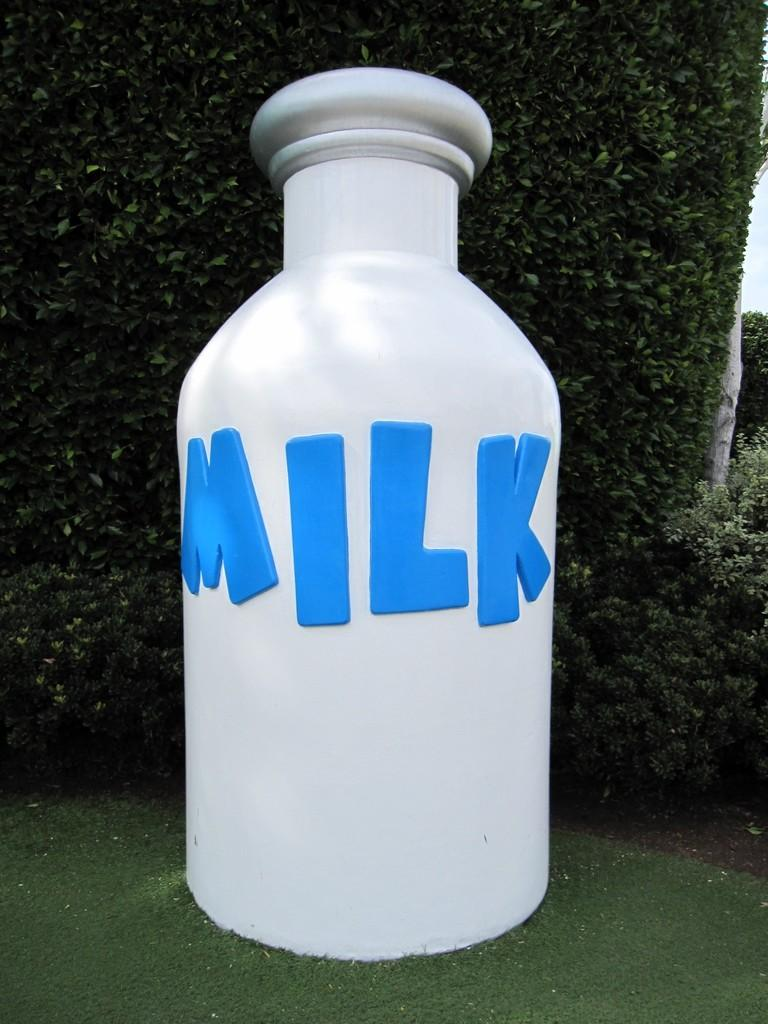<image>
Summarize the visual content of the image. An extremely large bottle of milk is sat on the lawn. 